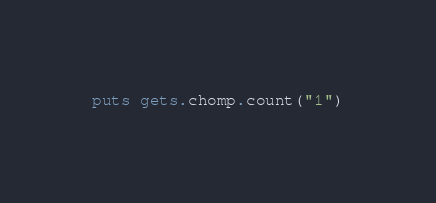Convert code to text. <code><loc_0><loc_0><loc_500><loc_500><_Ruby_>puts gets.chomp.count("1")
</code> 